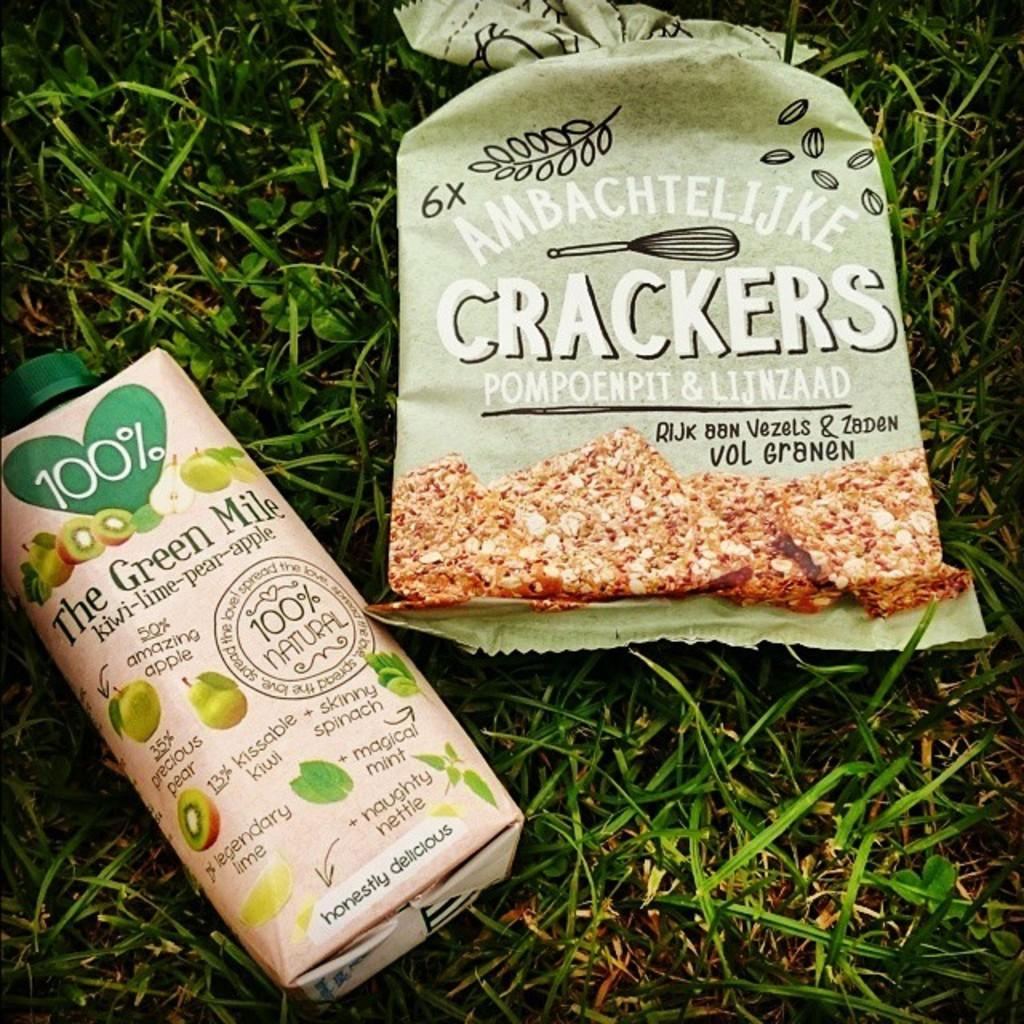<image>
Render a clear and concise summary of the photo. the word crackers is on the packaged item 